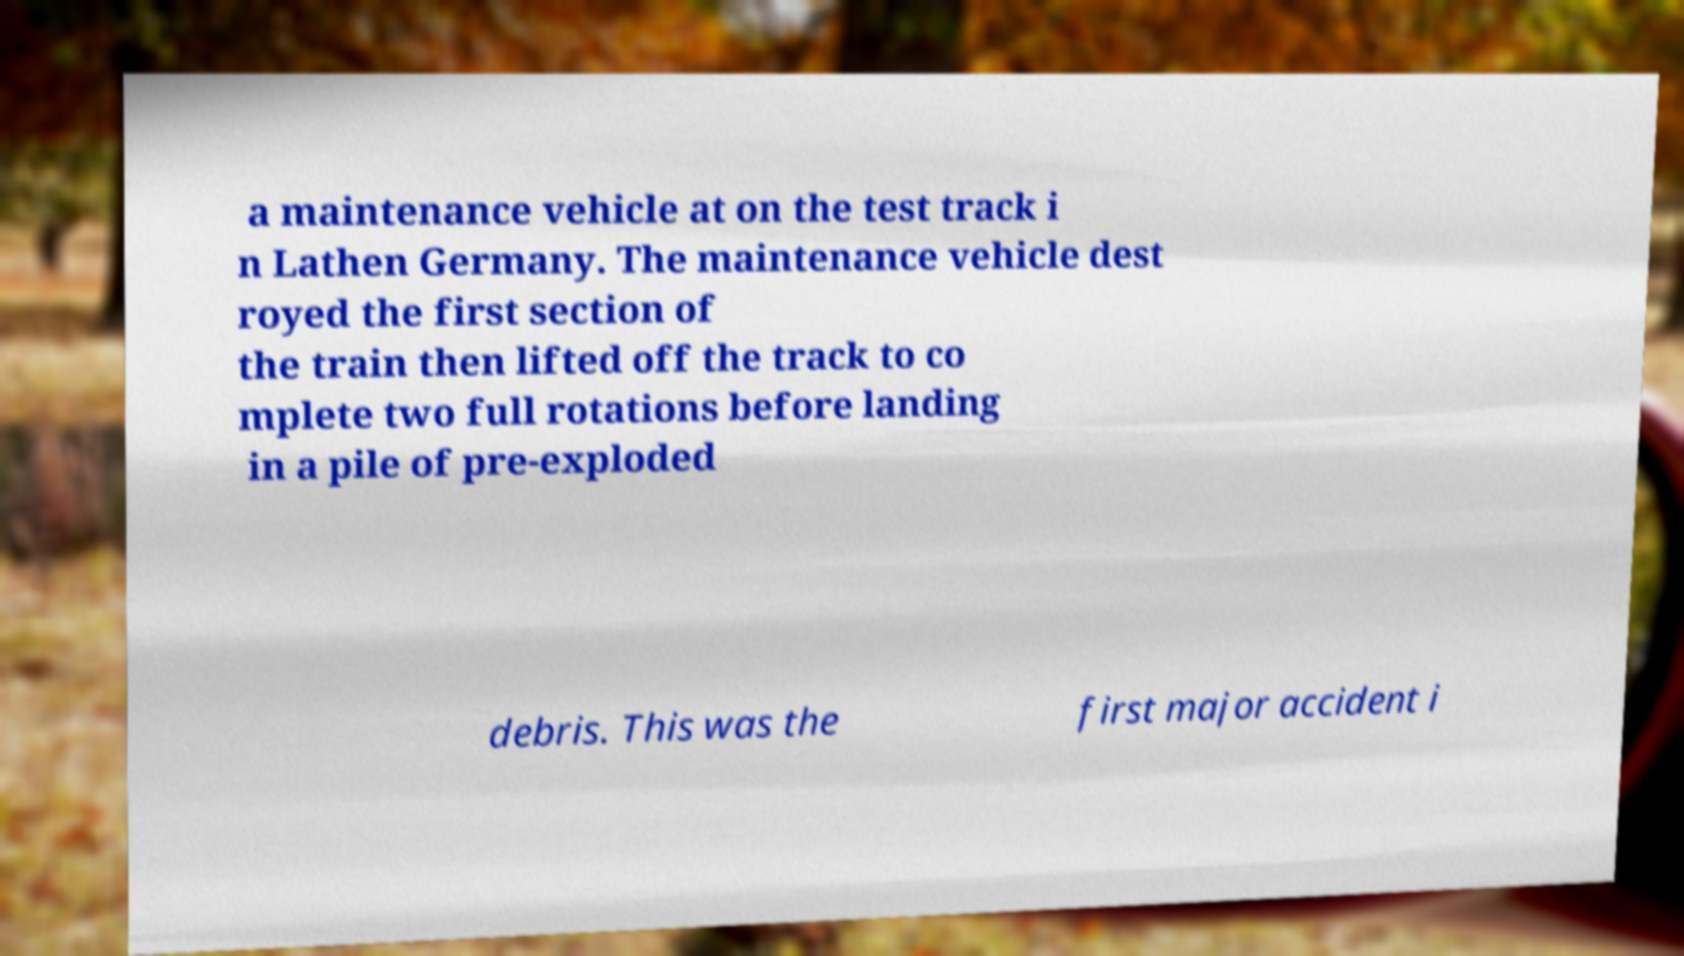Please identify and transcribe the text found in this image. a maintenance vehicle at on the test track i n Lathen Germany. The maintenance vehicle dest royed the first section of the train then lifted off the track to co mplete two full rotations before landing in a pile of pre-exploded debris. This was the first major accident i 